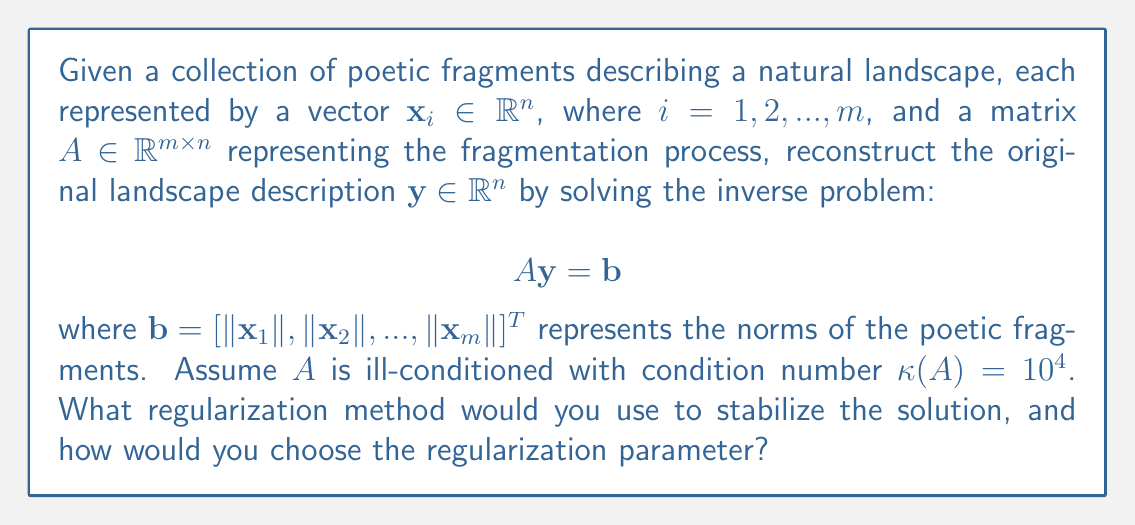Provide a solution to this math problem. To solve this inverse problem and reconstruct the natural landscape from fragmented poetic descriptions, we need to consider the following steps:

1. Recognize that this is an ill-posed problem due to the high condition number of $A$ ($\kappa(A) = 10^4$).

2. Choose a regularization method to stabilize the solution. In this case, Tikhonov regularization is appropriate:

   $$\min_{\mathbf{y}} \{\|A\mathbf{y} - \mathbf{b}\|_2^2 + \lambda\|\mathbf{y}\|_2^2\}$$

   where $\lambda > 0$ is the regularization parameter.

3. The solution to the Tikhonov-regularized problem is:

   $$\mathbf{y}_\lambda = (A^TA + \lambda I)^{-1}A^T\mathbf{b}$$

4. To choose the regularization parameter $\lambda$, we can use the L-curve method:
   a. Compute solutions $\mathbf{y}_\lambda$ for various $\lambda$ values.
   b. Plot the curve $(\log\|A\mathbf{y}_\lambda - \mathbf{b}\|_2, \log\|\mathbf{y}_\lambda\|_2)$.
   c. Choose $\lambda$ at the corner of the L-shaped curve.

5. Alternatively, we can use the Generalized Cross-Validation (GCV) method:
   a. Minimize the GCV function:
      $$G(\lambda) = \frac{\|A\mathbf{y}_\lambda - \mathbf{b}\|_2^2}{[\text{trace}(I - A(A^TA + \lambda I)^{-1}A^T)]^2}$$
   b. The $\lambda$ that minimizes $G(\lambda)$ is the optimal regularization parameter.

6. Once we have determined the optimal $\lambda$, we can compute the regularized solution $\mathbf{y}_\lambda$ to reconstruct the original landscape description.

This approach balances the fidelity to the data (poetic fragments) with the stability of the solution, allowing for a more accurate reconstruction of the natural landscape from the fragmented poetic descriptions.
Answer: Tikhonov regularization with L-curve or GCV for parameter selection 